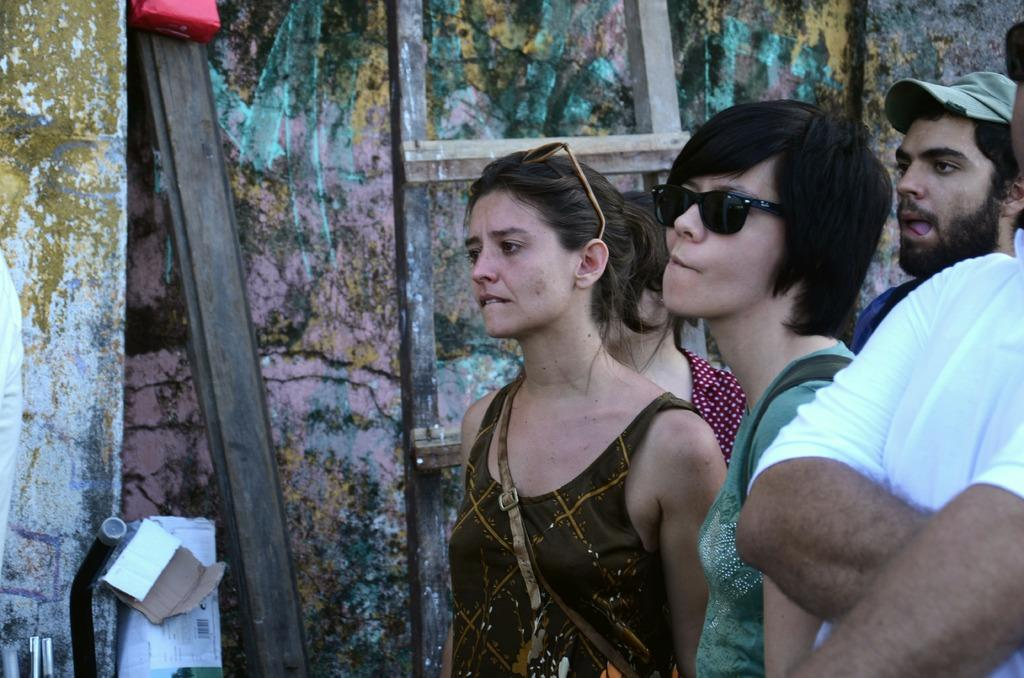How many people are in the image? There is a group of people in the image. Where are the people standing in relation to the wall? The people are standing beside the wall. What is on the wall in the image? There is a ladder and a big wooden piece on the wall, as well as other objects. What type of fuel is being used by the throne in the image? There is no throne present in the image, so the question about fuel is not applicable. 